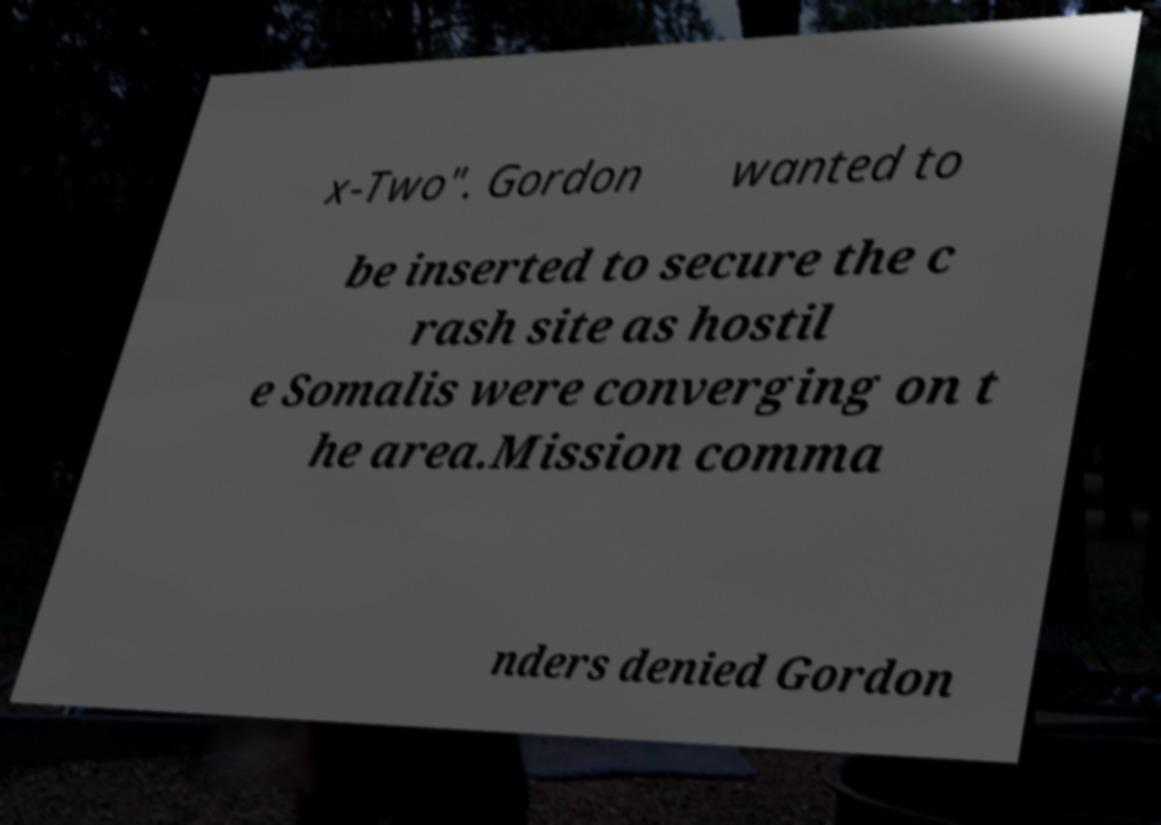Could you extract and type out the text from this image? x-Two". Gordon wanted to be inserted to secure the c rash site as hostil e Somalis were converging on t he area.Mission comma nders denied Gordon 